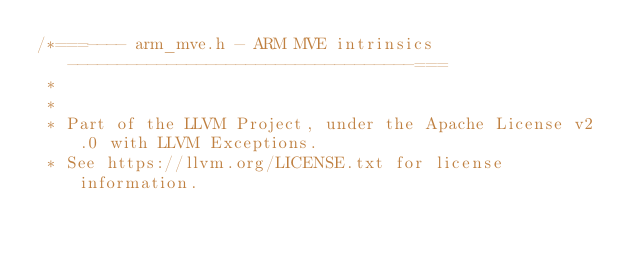<code> <loc_0><loc_0><loc_500><loc_500><_C_>/*===---- arm_mve.h - ARM MVE intrinsics -----------------------------------===
 *
 *
 * Part of the LLVM Project, under the Apache License v2.0 with LLVM Exceptions.
 * See https://llvm.org/LICENSE.txt for license information.</code> 